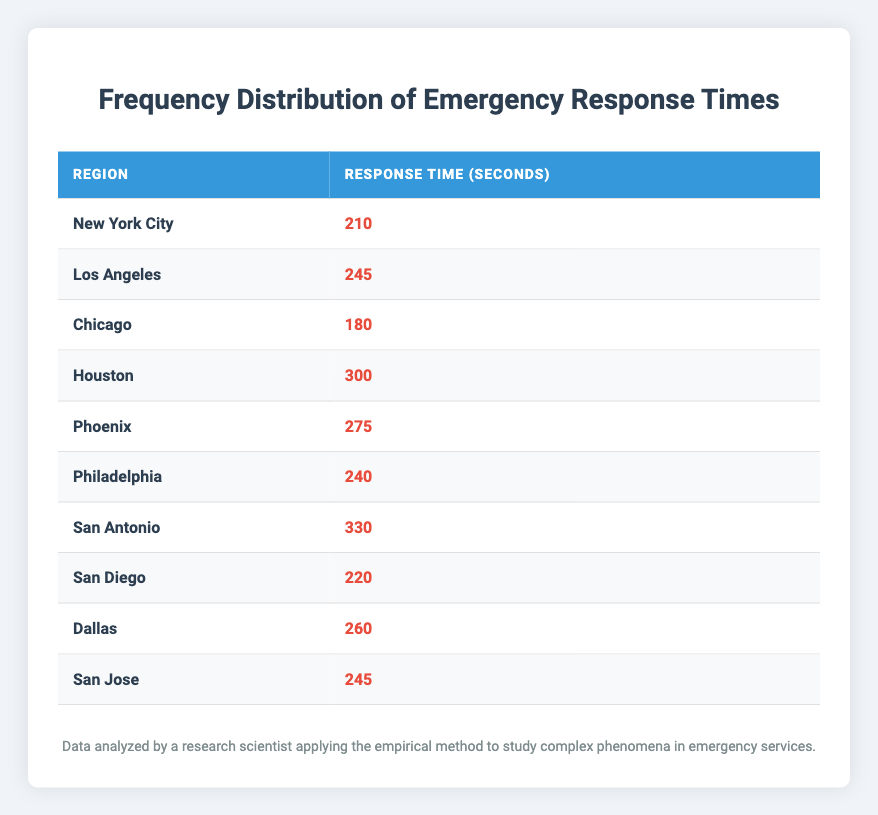What is the longest response time recorded in the table? The longest response time can be found by scanning through the 'Response Time (seconds)' column for the maximum value. The highest value is 330 seconds, associated with the region San Antonio.
Answer: 330 seconds Which region has the shortest response time? To find the shortest response time, review the response times in the table and identify the lowest value. The minimum value is 180 seconds, which corresponds to Chicago.
Answer: Chicago What is the average response time across all regions? To calculate the average, first sum the response times: 210 + 245 + 180 + 300 + 275 + 240 + 330 + 220 + 260 + 245 = 2455 seconds. Then divide the total by the number of regions (10): 2455 / 10 = 245.5 seconds.
Answer: 245.5 seconds Is the response time for Houston less than 250 seconds? Checking the response time for Houston, it is listed as 300 seconds. Since 300 is greater than 250, the answer is no.
Answer: No How many regions have a response time greater than 250 seconds? Count the number of regions in the table with response times exceeding 250 seconds. The regions with these times are Houston (300), Phoenix (275), and San Antonio (330), totaling 3 regions.
Answer: 3 regions What is the difference between the largest and smallest response times? Identify the largest response time, which is 330 seconds (San Antonio), and the smallest response time, which is 180 seconds (Chicago). The difference is calculated as 330 - 180 = 150 seconds.
Answer: 150 seconds Which regions have response times equal to or above 240 seconds? Filter the table for regions with response times of 240 seconds or more. The qualifying regions are Los Angeles (245), Philadelphia (240), Houston (300), Phoenix (275), San Antonio (330), Dallas (260), and San Jose (245). In total, there are 7 regions.
Answer: 7 regions Is Philadelphia's response time higher than that of San Diego? Comparing the response times, Philadelphia is 240 seconds and San Diego is 220 seconds. Since 240 is greater than 220, the answer is yes.
Answer: Yes What is the median response time among the regions? To find the median, first order the response times: 180, 210, 220, 240, 245, 245, 260, 275, 300, 330. Since there are 10 values, the median is the average of the 5th and 6th values (245 and 245), which is 245 seconds.
Answer: 245 seconds 